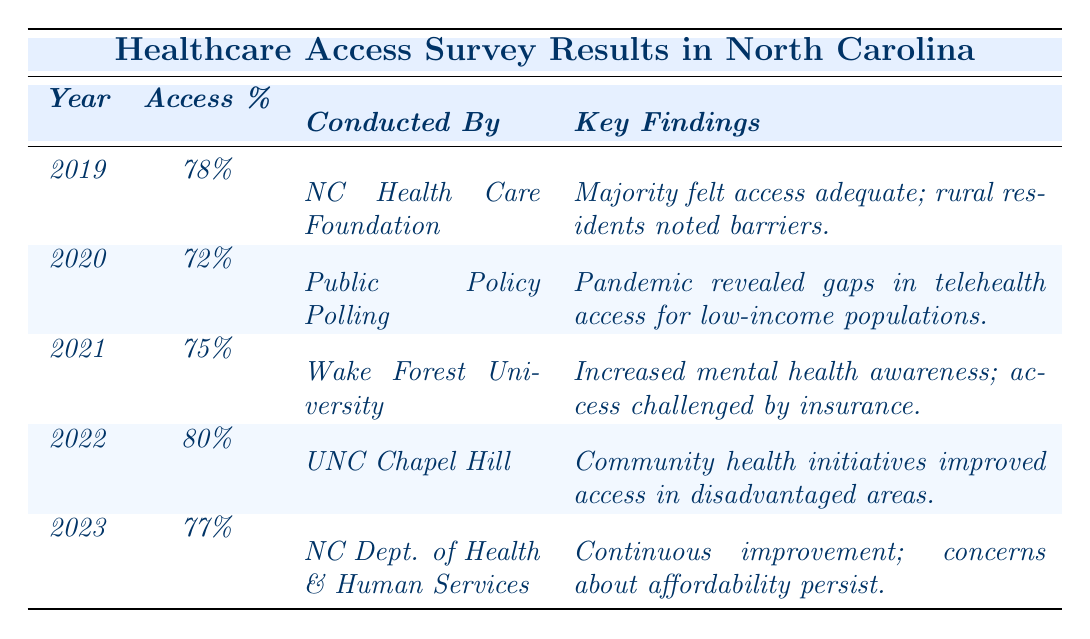What was the percentage of healthcare access in North Carolina in 2021? According to the table, the healthcare access percentage for the year 2021 is listed as 75%.
Answer: 75% Which year showed the highest percentage of healthcare access? The table indicates that the year 2022 had the highest percentage of access at 80%.
Answer: 2022 Did any of the surveys indicate a percentage access below 75%? Yes, the survey conducted in 2020 indicated a percentage access of 72%, which is below 75%.
Answer: Yes What trend can be observed in healthcare access from 2019 to 2023? In looking at the percentages, we see that healthcare access decreased from 78% in 2019 to 72% in 2020, then it increased to 75% in 2021, peaked at 80% in 2022, and finally settled at 77% in 2023.
Answer: Mixed trend with a peak in 2022 What was the average percentage of healthcare access over the five years? To find the average, sum the percentages of all five years (78 + 72 + 75 + 80 + 77 = 382) and divide by 5. The average is 382/5 = 76.4%.
Answer: 76.4% What concern was shared in the survey findings of 2023? The key findings for 2023 highlight concerns about affordability and insurance coverage, which were lingering issues despite continuous improvement in access.
Answer: Affordability and insurance coverage Which organization conducted the survey in 2020? The table states that the survey conducted in 2020 was by Public Policy Polling.
Answer: Public Policy Polling Was there a year where the access percentage decreased compared to the previous year? Yes, there was a decrease in 2020 when the percentage dropped from 78% in 2019 to 72% in 2020.
Answer: Yes What does the key finding for 2022 indicate about community health initiatives? The key finding for 2022 mentions that community health initiatives have led to improved access, particularly in disadvantaged communities.
Answer: Improved access in disadvantaged communities How many organizations conducted surveys in the given data? By reviewing the table, there are five different organizations that conducted the surveys from 2019 to 2023.
Answer: Five organizations What was the healthcare access percentage change from 2021 to 2023? The percentage was 75% in 2021 and decreased to 77% in 2023, resulting in a change of 2%.
Answer: Increased by 2% 